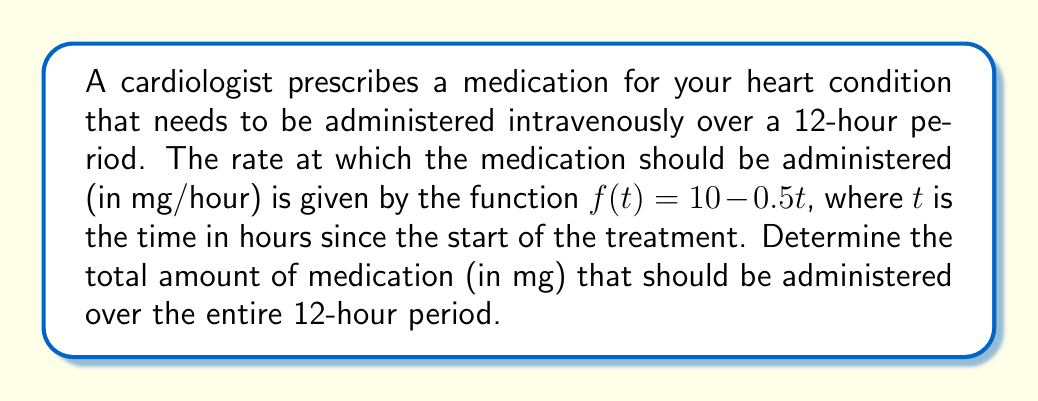Can you answer this question? To solve this problem, we need to integrate the rate function over the given time interval. The steps are as follows:

1) The rate function is given by $f(t) = 10 - 0.5t$ mg/hour.

2) We need to find the total amount of medication administered from $t=0$ to $t=12$ hours.

3) This can be calculated by integrating the rate function over this interval:

   $$\int_0^{12} (10 - 0.5t) dt$$

4) Let's solve this integral:
   
   $$\int_0^{12} (10 - 0.5t) dt = [10t - 0.25t^2]_0^{12}$$

5) Evaluate the integral:
   
   $$(10(12) - 0.25(12)^2) - (10(0) - 0.25(0)^2)$$
   
   $$= (120 - 36) - 0 = 84$$

Therefore, the total amount of medication administered over the 12-hour period is 84 mg.
Answer: 84 mg 